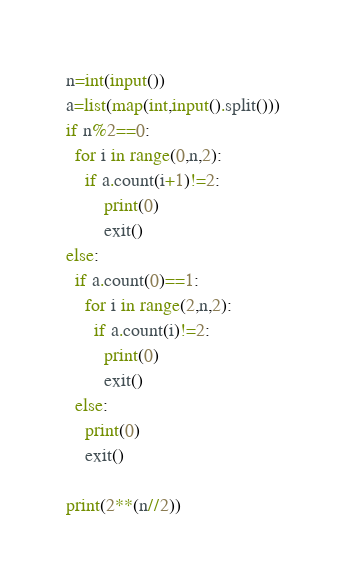<code> <loc_0><loc_0><loc_500><loc_500><_Python_>n=int(input())
a=list(map(int,input().split()))
if n%2==0:
  for i in range(0,n,2):
    if a.count(i+1)!=2:
        print(0)
        exit()
else:
  if a.count(0)==1:
    for i in range(2,n,2):
      if a.count(i)!=2:
        print(0)
        exit()
  else:
    print(0)
    exit()
    
print(2**(n//2))</code> 